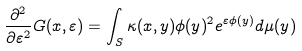Convert formula to latex. <formula><loc_0><loc_0><loc_500><loc_500>\frac { \partial ^ { 2 } } { \partial \varepsilon ^ { 2 } } G ( x , \varepsilon ) = \int _ { S } \kappa ( x , y ) \phi ( y ) ^ { 2 } e ^ { \varepsilon \phi ( y ) } d \mu ( y )</formula> 